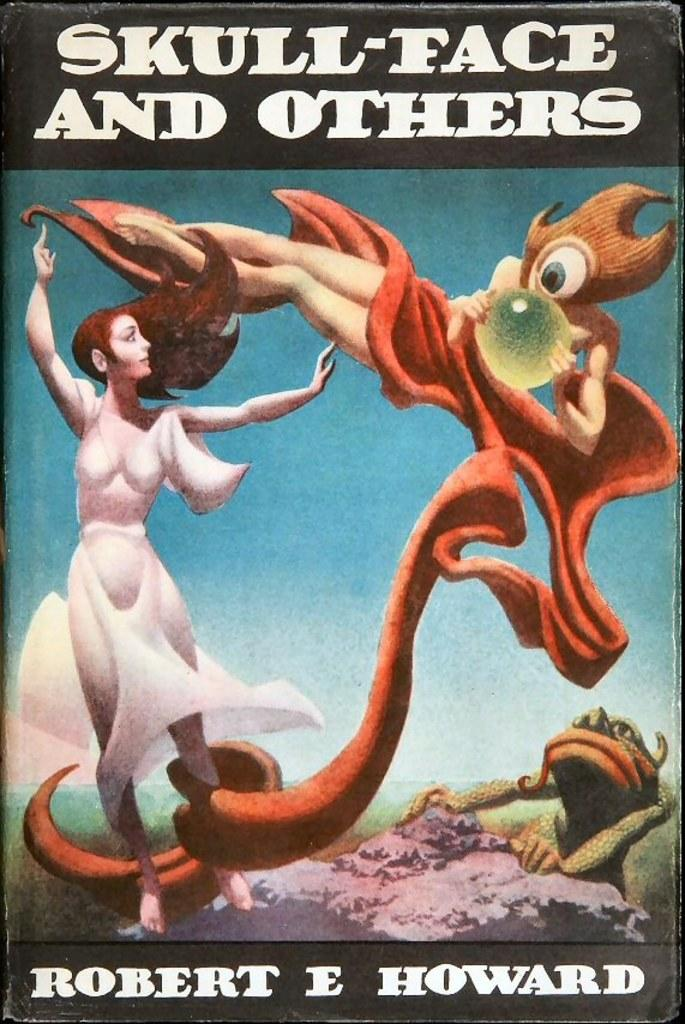What is the main subject in the image? There is a lady standing in the image. What else can be seen in the image besides the lady? There is an animal on a rock in the image. What type of text is present in the image? There is text at the top and bottom of the image. What is the reason for the town being covered in snow in the image? There is no town or snow present in the image; it features a lady standing and an animal on a rock. 